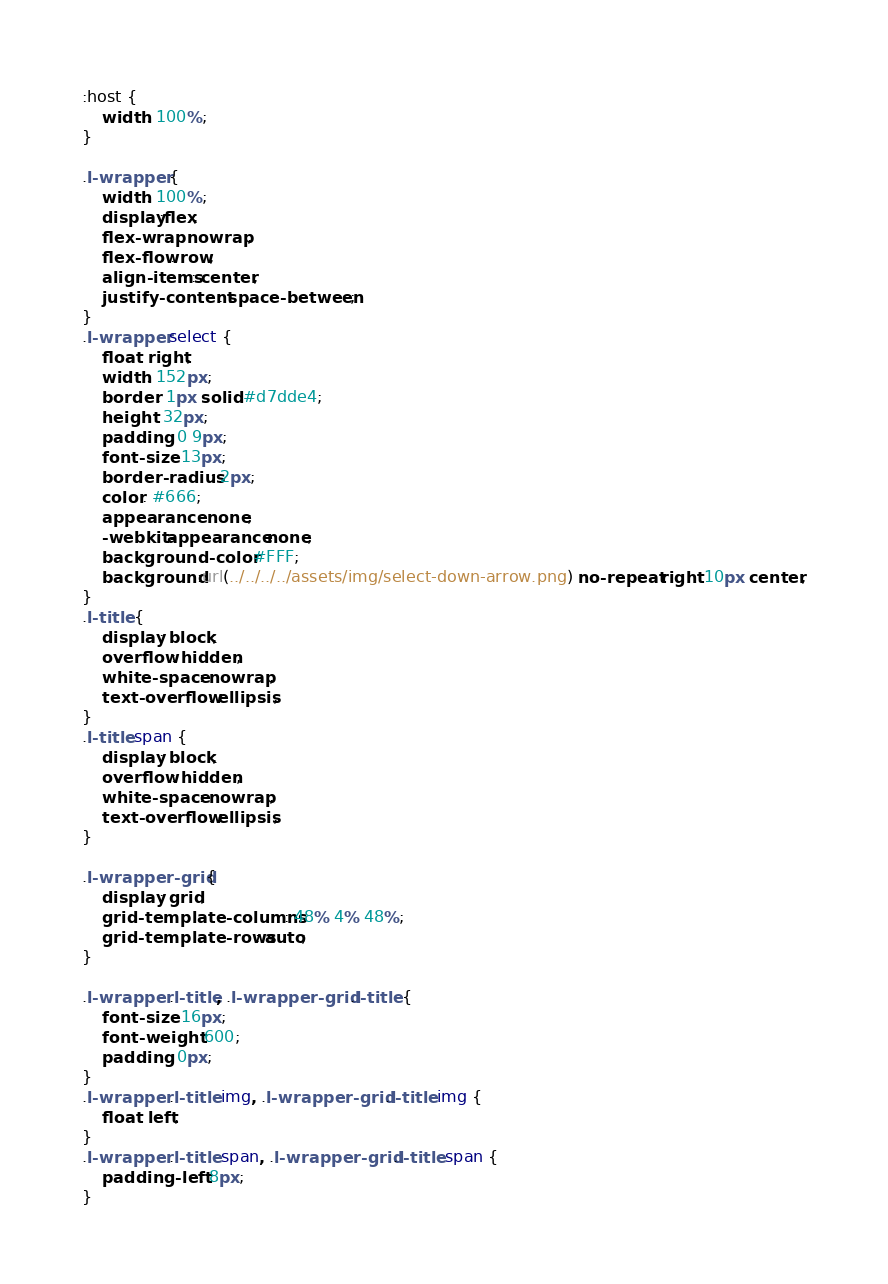Convert code to text. <code><loc_0><loc_0><loc_500><loc_500><_CSS_>:host {
    width: 100%;
}

.l-wrapper {
    width: 100%;
    display:flex;
    flex-wrap: nowrap;
    flex-flow: row;
    align-items: center;
    justify-content: space-between;
}
.l-wrapper select {
    float: right;
    width: 152px;
    border: 1px solid #d7dde4;
    height: 32px;
    padding: 0 9px;
    font-size: 13px;
    border-radius: 2px;
    color: #666;
    appearance: none;
    -webkit-appearance:none;
    background-color: #FFF;
    background:url(../../../../assets/img/select-down-arrow.png) no-repeat right 10px center;
}
.l-title {
    display: block;
    overflow: hidden;
    white-space: nowrap;
    text-overflow: ellipsis;
}
.l-title span {
    display: block;
    overflow: hidden;
    white-space: nowrap;
    text-overflow: ellipsis;
}

.l-wrapper-grid {
    display: grid;
    grid-template-columns: 48% 4% 48%;
    grid-template-rows: auto;
}

.l-wrapper .l-title, .l-wrapper-grid .l-title {
    font-size: 16px;
    font-weight: 600;
    padding: 0px;
}
.l-wrapper .l-title img, .l-wrapper-grid .l-title img {
    float: left;
}
.l-wrapper .l-title span, .l-wrapper-grid .l-title span {
    padding-left: 8px;
}
</code> 